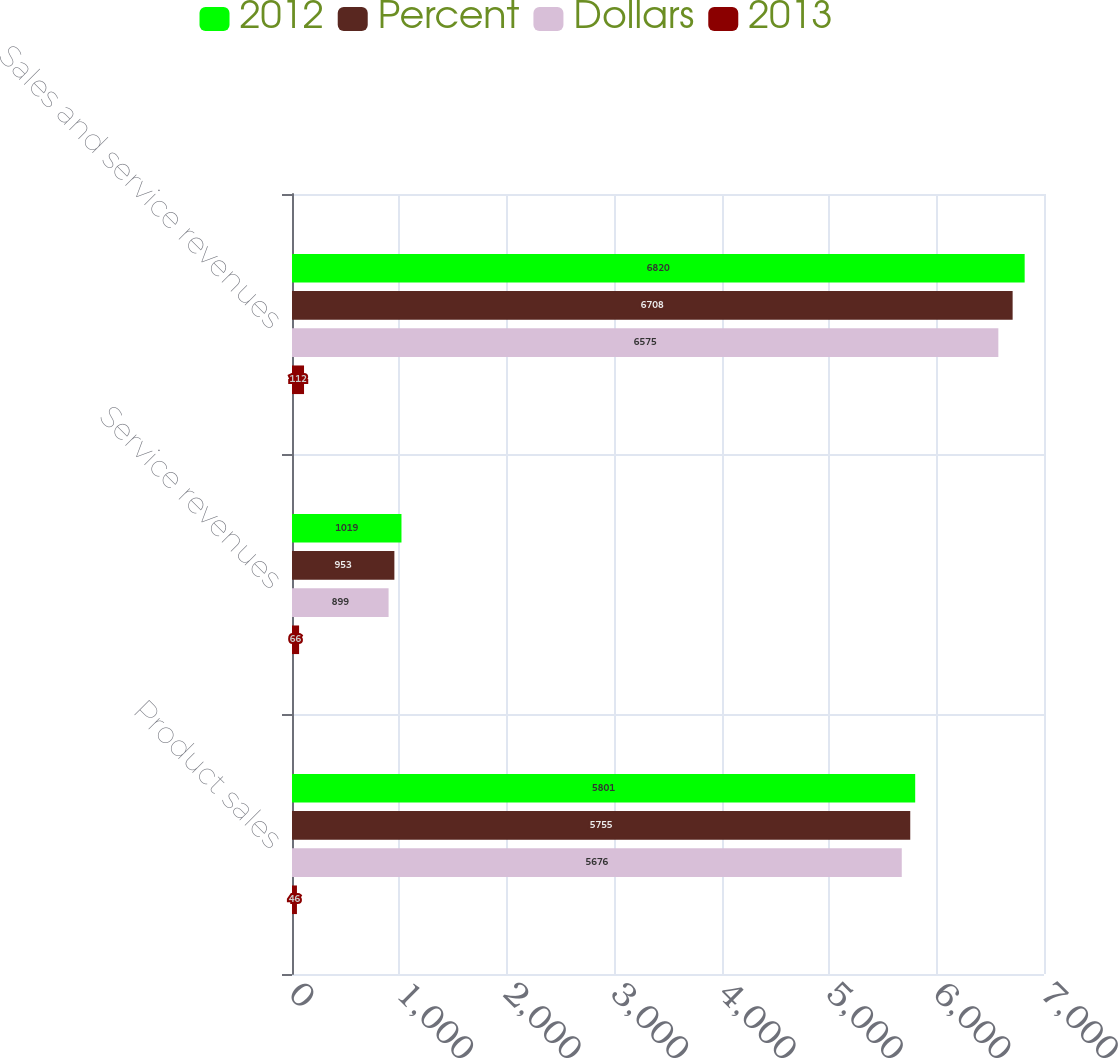Convert chart. <chart><loc_0><loc_0><loc_500><loc_500><stacked_bar_chart><ecel><fcel>Product sales<fcel>Service revenues<fcel>Sales and service revenues<nl><fcel>2012<fcel>5801<fcel>1019<fcel>6820<nl><fcel>Percent<fcel>5755<fcel>953<fcel>6708<nl><fcel>Dollars<fcel>5676<fcel>899<fcel>6575<nl><fcel>2013<fcel>46<fcel>66<fcel>112<nl></chart> 